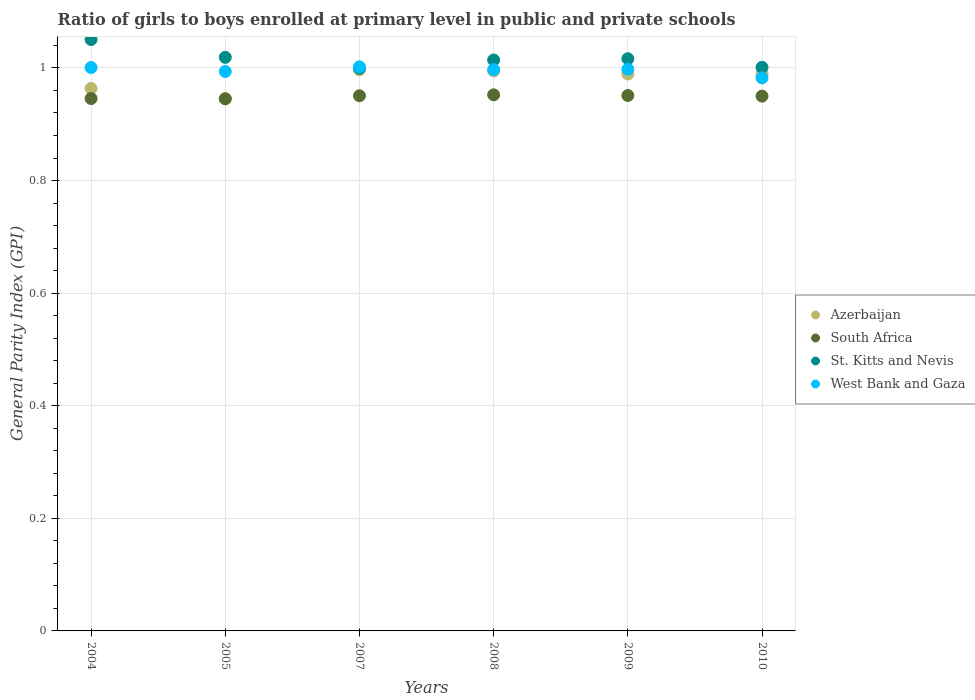Is the number of dotlines equal to the number of legend labels?
Your answer should be very brief. Yes. What is the general parity index in West Bank and Gaza in 2005?
Provide a short and direct response. 0.99. Across all years, what is the maximum general parity index in South Africa?
Give a very brief answer. 0.95. Across all years, what is the minimum general parity index in Azerbaijan?
Your answer should be very brief. 0.95. What is the total general parity index in West Bank and Gaza in the graph?
Give a very brief answer. 5.97. What is the difference between the general parity index in South Africa in 2009 and that in 2010?
Offer a very short reply. 0. What is the difference between the general parity index in South Africa in 2005 and the general parity index in Azerbaijan in 2009?
Give a very brief answer. -0.04. What is the average general parity index in West Bank and Gaza per year?
Offer a terse response. 1. In the year 2004, what is the difference between the general parity index in Azerbaijan and general parity index in South Africa?
Make the answer very short. 0.02. In how many years, is the general parity index in Azerbaijan greater than 0.7200000000000001?
Offer a very short reply. 6. What is the ratio of the general parity index in St. Kitts and Nevis in 2004 to that in 2009?
Ensure brevity in your answer.  1.03. Is the difference between the general parity index in Azerbaijan in 2009 and 2010 greater than the difference between the general parity index in South Africa in 2009 and 2010?
Give a very brief answer. No. What is the difference between the highest and the second highest general parity index in South Africa?
Give a very brief answer. 0. What is the difference between the highest and the lowest general parity index in West Bank and Gaza?
Offer a terse response. 0.02. Is the sum of the general parity index in West Bank and Gaza in 2007 and 2009 greater than the maximum general parity index in St. Kitts and Nevis across all years?
Make the answer very short. Yes. Is it the case that in every year, the sum of the general parity index in Azerbaijan and general parity index in West Bank and Gaza  is greater than the general parity index in St. Kitts and Nevis?
Offer a very short reply. Yes. Does the general parity index in St. Kitts and Nevis monotonically increase over the years?
Offer a very short reply. No. Is the general parity index in West Bank and Gaza strictly greater than the general parity index in St. Kitts and Nevis over the years?
Your answer should be compact. No. Is the general parity index in Azerbaijan strictly less than the general parity index in St. Kitts and Nevis over the years?
Provide a short and direct response. Yes. How many dotlines are there?
Ensure brevity in your answer.  4. Are the values on the major ticks of Y-axis written in scientific E-notation?
Provide a short and direct response. No. Does the graph contain any zero values?
Your answer should be compact. No. Where does the legend appear in the graph?
Your answer should be very brief. Center right. How are the legend labels stacked?
Your response must be concise. Vertical. What is the title of the graph?
Give a very brief answer. Ratio of girls to boys enrolled at primary level in public and private schools. What is the label or title of the Y-axis?
Your response must be concise. General Parity Index (GPI). What is the General Parity Index (GPI) of Azerbaijan in 2004?
Provide a succinct answer. 0.96. What is the General Parity Index (GPI) in South Africa in 2004?
Give a very brief answer. 0.95. What is the General Parity Index (GPI) in St. Kitts and Nevis in 2004?
Make the answer very short. 1.05. What is the General Parity Index (GPI) in West Bank and Gaza in 2004?
Make the answer very short. 1. What is the General Parity Index (GPI) in Azerbaijan in 2005?
Ensure brevity in your answer.  0.95. What is the General Parity Index (GPI) of South Africa in 2005?
Your answer should be very brief. 0.95. What is the General Parity Index (GPI) in St. Kitts and Nevis in 2005?
Provide a short and direct response. 1.02. What is the General Parity Index (GPI) of West Bank and Gaza in 2005?
Offer a very short reply. 0.99. What is the General Parity Index (GPI) in Azerbaijan in 2007?
Ensure brevity in your answer.  1. What is the General Parity Index (GPI) of South Africa in 2007?
Your answer should be compact. 0.95. What is the General Parity Index (GPI) in St. Kitts and Nevis in 2007?
Ensure brevity in your answer.  1. What is the General Parity Index (GPI) in West Bank and Gaza in 2007?
Give a very brief answer. 1. What is the General Parity Index (GPI) in Azerbaijan in 2008?
Provide a short and direct response. 0.99. What is the General Parity Index (GPI) in South Africa in 2008?
Offer a very short reply. 0.95. What is the General Parity Index (GPI) of St. Kitts and Nevis in 2008?
Ensure brevity in your answer.  1.01. What is the General Parity Index (GPI) in West Bank and Gaza in 2008?
Ensure brevity in your answer.  1. What is the General Parity Index (GPI) in Azerbaijan in 2009?
Give a very brief answer. 0.99. What is the General Parity Index (GPI) in South Africa in 2009?
Give a very brief answer. 0.95. What is the General Parity Index (GPI) in St. Kitts and Nevis in 2009?
Your answer should be very brief. 1.02. What is the General Parity Index (GPI) of West Bank and Gaza in 2009?
Give a very brief answer. 1. What is the General Parity Index (GPI) in Azerbaijan in 2010?
Provide a succinct answer. 0.99. What is the General Parity Index (GPI) of South Africa in 2010?
Provide a succinct answer. 0.95. What is the General Parity Index (GPI) of St. Kitts and Nevis in 2010?
Offer a very short reply. 1. What is the General Parity Index (GPI) in West Bank and Gaza in 2010?
Give a very brief answer. 0.98. Across all years, what is the maximum General Parity Index (GPI) in Azerbaijan?
Your answer should be compact. 1. Across all years, what is the maximum General Parity Index (GPI) in South Africa?
Provide a short and direct response. 0.95. Across all years, what is the maximum General Parity Index (GPI) of St. Kitts and Nevis?
Provide a short and direct response. 1.05. Across all years, what is the maximum General Parity Index (GPI) of West Bank and Gaza?
Keep it short and to the point. 1. Across all years, what is the minimum General Parity Index (GPI) of Azerbaijan?
Provide a succinct answer. 0.95. Across all years, what is the minimum General Parity Index (GPI) in South Africa?
Your answer should be very brief. 0.95. Across all years, what is the minimum General Parity Index (GPI) of St. Kitts and Nevis?
Offer a terse response. 1. Across all years, what is the minimum General Parity Index (GPI) in West Bank and Gaza?
Give a very brief answer. 0.98. What is the total General Parity Index (GPI) of Azerbaijan in the graph?
Your answer should be compact. 5.88. What is the total General Parity Index (GPI) of South Africa in the graph?
Your answer should be compact. 5.7. What is the total General Parity Index (GPI) in St. Kitts and Nevis in the graph?
Ensure brevity in your answer.  6.1. What is the total General Parity Index (GPI) of West Bank and Gaza in the graph?
Your response must be concise. 5.97. What is the difference between the General Parity Index (GPI) in Azerbaijan in 2004 and that in 2005?
Give a very brief answer. 0.02. What is the difference between the General Parity Index (GPI) in St. Kitts and Nevis in 2004 and that in 2005?
Offer a terse response. 0.03. What is the difference between the General Parity Index (GPI) in West Bank and Gaza in 2004 and that in 2005?
Offer a very short reply. 0.01. What is the difference between the General Parity Index (GPI) of Azerbaijan in 2004 and that in 2007?
Offer a terse response. -0.03. What is the difference between the General Parity Index (GPI) in South Africa in 2004 and that in 2007?
Your response must be concise. -0. What is the difference between the General Parity Index (GPI) in St. Kitts and Nevis in 2004 and that in 2007?
Your answer should be compact. 0.05. What is the difference between the General Parity Index (GPI) of West Bank and Gaza in 2004 and that in 2007?
Provide a succinct answer. -0. What is the difference between the General Parity Index (GPI) of Azerbaijan in 2004 and that in 2008?
Provide a short and direct response. -0.03. What is the difference between the General Parity Index (GPI) in South Africa in 2004 and that in 2008?
Offer a very short reply. -0.01. What is the difference between the General Parity Index (GPI) in St. Kitts and Nevis in 2004 and that in 2008?
Provide a succinct answer. 0.04. What is the difference between the General Parity Index (GPI) of West Bank and Gaza in 2004 and that in 2008?
Offer a very short reply. 0. What is the difference between the General Parity Index (GPI) of Azerbaijan in 2004 and that in 2009?
Keep it short and to the point. -0.03. What is the difference between the General Parity Index (GPI) of South Africa in 2004 and that in 2009?
Your answer should be very brief. -0.01. What is the difference between the General Parity Index (GPI) of St. Kitts and Nevis in 2004 and that in 2009?
Your answer should be very brief. 0.03. What is the difference between the General Parity Index (GPI) of West Bank and Gaza in 2004 and that in 2009?
Make the answer very short. 0. What is the difference between the General Parity Index (GPI) of Azerbaijan in 2004 and that in 2010?
Ensure brevity in your answer.  -0.03. What is the difference between the General Parity Index (GPI) of South Africa in 2004 and that in 2010?
Provide a short and direct response. -0. What is the difference between the General Parity Index (GPI) in St. Kitts and Nevis in 2004 and that in 2010?
Keep it short and to the point. 0.05. What is the difference between the General Parity Index (GPI) of West Bank and Gaza in 2004 and that in 2010?
Keep it short and to the point. 0.02. What is the difference between the General Parity Index (GPI) in Azerbaijan in 2005 and that in 2007?
Keep it short and to the point. -0.05. What is the difference between the General Parity Index (GPI) of South Africa in 2005 and that in 2007?
Offer a terse response. -0.01. What is the difference between the General Parity Index (GPI) in St. Kitts and Nevis in 2005 and that in 2007?
Provide a short and direct response. 0.02. What is the difference between the General Parity Index (GPI) of West Bank and Gaza in 2005 and that in 2007?
Provide a succinct answer. -0.01. What is the difference between the General Parity Index (GPI) in Azerbaijan in 2005 and that in 2008?
Your answer should be very brief. -0.05. What is the difference between the General Parity Index (GPI) in South Africa in 2005 and that in 2008?
Your response must be concise. -0.01. What is the difference between the General Parity Index (GPI) in St. Kitts and Nevis in 2005 and that in 2008?
Your answer should be compact. 0. What is the difference between the General Parity Index (GPI) in West Bank and Gaza in 2005 and that in 2008?
Make the answer very short. -0. What is the difference between the General Parity Index (GPI) in Azerbaijan in 2005 and that in 2009?
Ensure brevity in your answer.  -0.04. What is the difference between the General Parity Index (GPI) of South Africa in 2005 and that in 2009?
Ensure brevity in your answer.  -0.01. What is the difference between the General Parity Index (GPI) in St. Kitts and Nevis in 2005 and that in 2009?
Offer a terse response. 0. What is the difference between the General Parity Index (GPI) of West Bank and Gaza in 2005 and that in 2009?
Your answer should be compact. -0. What is the difference between the General Parity Index (GPI) of Azerbaijan in 2005 and that in 2010?
Keep it short and to the point. -0.04. What is the difference between the General Parity Index (GPI) of South Africa in 2005 and that in 2010?
Your answer should be compact. -0. What is the difference between the General Parity Index (GPI) in St. Kitts and Nevis in 2005 and that in 2010?
Make the answer very short. 0.02. What is the difference between the General Parity Index (GPI) of West Bank and Gaza in 2005 and that in 2010?
Provide a succinct answer. 0.01. What is the difference between the General Parity Index (GPI) in Azerbaijan in 2007 and that in 2008?
Ensure brevity in your answer.  0. What is the difference between the General Parity Index (GPI) in South Africa in 2007 and that in 2008?
Provide a short and direct response. -0. What is the difference between the General Parity Index (GPI) in St. Kitts and Nevis in 2007 and that in 2008?
Provide a succinct answer. -0.01. What is the difference between the General Parity Index (GPI) in West Bank and Gaza in 2007 and that in 2008?
Keep it short and to the point. 0. What is the difference between the General Parity Index (GPI) of Azerbaijan in 2007 and that in 2009?
Provide a short and direct response. 0.01. What is the difference between the General Parity Index (GPI) in South Africa in 2007 and that in 2009?
Give a very brief answer. -0. What is the difference between the General Parity Index (GPI) in St. Kitts and Nevis in 2007 and that in 2009?
Ensure brevity in your answer.  -0.02. What is the difference between the General Parity Index (GPI) of West Bank and Gaza in 2007 and that in 2009?
Your response must be concise. 0. What is the difference between the General Parity Index (GPI) in Azerbaijan in 2007 and that in 2010?
Provide a succinct answer. 0.01. What is the difference between the General Parity Index (GPI) in South Africa in 2007 and that in 2010?
Ensure brevity in your answer.  0. What is the difference between the General Parity Index (GPI) in St. Kitts and Nevis in 2007 and that in 2010?
Offer a terse response. -0. What is the difference between the General Parity Index (GPI) in West Bank and Gaza in 2007 and that in 2010?
Provide a succinct answer. 0.02. What is the difference between the General Parity Index (GPI) in Azerbaijan in 2008 and that in 2009?
Keep it short and to the point. 0.01. What is the difference between the General Parity Index (GPI) in South Africa in 2008 and that in 2009?
Your answer should be compact. 0. What is the difference between the General Parity Index (GPI) in St. Kitts and Nevis in 2008 and that in 2009?
Provide a succinct answer. -0. What is the difference between the General Parity Index (GPI) of West Bank and Gaza in 2008 and that in 2009?
Offer a very short reply. -0. What is the difference between the General Parity Index (GPI) in Azerbaijan in 2008 and that in 2010?
Provide a short and direct response. 0.01. What is the difference between the General Parity Index (GPI) of South Africa in 2008 and that in 2010?
Offer a very short reply. 0. What is the difference between the General Parity Index (GPI) of St. Kitts and Nevis in 2008 and that in 2010?
Give a very brief answer. 0.01. What is the difference between the General Parity Index (GPI) of West Bank and Gaza in 2008 and that in 2010?
Provide a succinct answer. 0.01. What is the difference between the General Parity Index (GPI) of Azerbaijan in 2009 and that in 2010?
Your response must be concise. -0. What is the difference between the General Parity Index (GPI) of South Africa in 2009 and that in 2010?
Provide a succinct answer. 0. What is the difference between the General Parity Index (GPI) of St. Kitts and Nevis in 2009 and that in 2010?
Make the answer very short. 0.02. What is the difference between the General Parity Index (GPI) in West Bank and Gaza in 2009 and that in 2010?
Provide a short and direct response. 0.02. What is the difference between the General Parity Index (GPI) of Azerbaijan in 2004 and the General Parity Index (GPI) of South Africa in 2005?
Provide a short and direct response. 0.02. What is the difference between the General Parity Index (GPI) of Azerbaijan in 2004 and the General Parity Index (GPI) of St. Kitts and Nevis in 2005?
Offer a very short reply. -0.06. What is the difference between the General Parity Index (GPI) of Azerbaijan in 2004 and the General Parity Index (GPI) of West Bank and Gaza in 2005?
Offer a very short reply. -0.03. What is the difference between the General Parity Index (GPI) of South Africa in 2004 and the General Parity Index (GPI) of St. Kitts and Nevis in 2005?
Ensure brevity in your answer.  -0.07. What is the difference between the General Parity Index (GPI) in South Africa in 2004 and the General Parity Index (GPI) in West Bank and Gaza in 2005?
Give a very brief answer. -0.05. What is the difference between the General Parity Index (GPI) in St. Kitts and Nevis in 2004 and the General Parity Index (GPI) in West Bank and Gaza in 2005?
Offer a terse response. 0.06. What is the difference between the General Parity Index (GPI) in Azerbaijan in 2004 and the General Parity Index (GPI) in South Africa in 2007?
Offer a very short reply. 0.01. What is the difference between the General Parity Index (GPI) in Azerbaijan in 2004 and the General Parity Index (GPI) in St. Kitts and Nevis in 2007?
Make the answer very short. -0.04. What is the difference between the General Parity Index (GPI) in Azerbaijan in 2004 and the General Parity Index (GPI) in West Bank and Gaza in 2007?
Ensure brevity in your answer.  -0.04. What is the difference between the General Parity Index (GPI) in South Africa in 2004 and the General Parity Index (GPI) in St. Kitts and Nevis in 2007?
Keep it short and to the point. -0.05. What is the difference between the General Parity Index (GPI) of South Africa in 2004 and the General Parity Index (GPI) of West Bank and Gaza in 2007?
Offer a terse response. -0.06. What is the difference between the General Parity Index (GPI) in St. Kitts and Nevis in 2004 and the General Parity Index (GPI) in West Bank and Gaza in 2007?
Provide a short and direct response. 0.05. What is the difference between the General Parity Index (GPI) in Azerbaijan in 2004 and the General Parity Index (GPI) in South Africa in 2008?
Your response must be concise. 0.01. What is the difference between the General Parity Index (GPI) in Azerbaijan in 2004 and the General Parity Index (GPI) in St. Kitts and Nevis in 2008?
Your answer should be compact. -0.05. What is the difference between the General Parity Index (GPI) in Azerbaijan in 2004 and the General Parity Index (GPI) in West Bank and Gaza in 2008?
Ensure brevity in your answer.  -0.03. What is the difference between the General Parity Index (GPI) of South Africa in 2004 and the General Parity Index (GPI) of St. Kitts and Nevis in 2008?
Provide a succinct answer. -0.07. What is the difference between the General Parity Index (GPI) of South Africa in 2004 and the General Parity Index (GPI) of West Bank and Gaza in 2008?
Your answer should be very brief. -0.05. What is the difference between the General Parity Index (GPI) of St. Kitts and Nevis in 2004 and the General Parity Index (GPI) of West Bank and Gaza in 2008?
Your answer should be compact. 0.05. What is the difference between the General Parity Index (GPI) of Azerbaijan in 2004 and the General Parity Index (GPI) of South Africa in 2009?
Your answer should be compact. 0.01. What is the difference between the General Parity Index (GPI) in Azerbaijan in 2004 and the General Parity Index (GPI) in St. Kitts and Nevis in 2009?
Keep it short and to the point. -0.05. What is the difference between the General Parity Index (GPI) of Azerbaijan in 2004 and the General Parity Index (GPI) of West Bank and Gaza in 2009?
Give a very brief answer. -0.03. What is the difference between the General Parity Index (GPI) in South Africa in 2004 and the General Parity Index (GPI) in St. Kitts and Nevis in 2009?
Your answer should be compact. -0.07. What is the difference between the General Parity Index (GPI) in South Africa in 2004 and the General Parity Index (GPI) in West Bank and Gaza in 2009?
Your answer should be very brief. -0.05. What is the difference between the General Parity Index (GPI) of St. Kitts and Nevis in 2004 and the General Parity Index (GPI) of West Bank and Gaza in 2009?
Your answer should be compact. 0.05. What is the difference between the General Parity Index (GPI) of Azerbaijan in 2004 and the General Parity Index (GPI) of South Africa in 2010?
Provide a short and direct response. 0.01. What is the difference between the General Parity Index (GPI) of Azerbaijan in 2004 and the General Parity Index (GPI) of St. Kitts and Nevis in 2010?
Provide a succinct answer. -0.04. What is the difference between the General Parity Index (GPI) in Azerbaijan in 2004 and the General Parity Index (GPI) in West Bank and Gaza in 2010?
Keep it short and to the point. -0.02. What is the difference between the General Parity Index (GPI) in South Africa in 2004 and the General Parity Index (GPI) in St. Kitts and Nevis in 2010?
Make the answer very short. -0.06. What is the difference between the General Parity Index (GPI) of South Africa in 2004 and the General Parity Index (GPI) of West Bank and Gaza in 2010?
Ensure brevity in your answer.  -0.04. What is the difference between the General Parity Index (GPI) in St. Kitts and Nevis in 2004 and the General Parity Index (GPI) in West Bank and Gaza in 2010?
Make the answer very short. 0.07. What is the difference between the General Parity Index (GPI) in Azerbaijan in 2005 and the General Parity Index (GPI) in South Africa in 2007?
Offer a terse response. -0.01. What is the difference between the General Parity Index (GPI) in Azerbaijan in 2005 and the General Parity Index (GPI) in St. Kitts and Nevis in 2007?
Offer a terse response. -0.05. What is the difference between the General Parity Index (GPI) in Azerbaijan in 2005 and the General Parity Index (GPI) in West Bank and Gaza in 2007?
Offer a very short reply. -0.06. What is the difference between the General Parity Index (GPI) in South Africa in 2005 and the General Parity Index (GPI) in St. Kitts and Nevis in 2007?
Offer a terse response. -0.05. What is the difference between the General Parity Index (GPI) in South Africa in 2005 and the General Parity Index (GPI) in West Bank and Gaza in 2007?
Offer a very short reply. -0.06. What is the difference between the General Parity Index (GPI) in St. Kitts and Nevis in 2005 and the General Parity Index (GPI) in West Bank and Gaza in 2007?
Keep it short and to the point. 0.02. What is the difference between the General Parity Index (GPI) in Azerbaijan in 2005 and the General Parity Index (GPI) in South Africa in 2008?
Your response must be concise. -0.01. What is the difference between the General Parity Index (GPI) of Azerbaijan in 2005 and the General Parity Index (GPI) of St. Kitts and Nevis in 2008?
Keep it short and to the point. -0.07. What is the difference between the General Parity Index (GPI) in Azerbaijan in 2005 and the General Parity Index (GPI) in West Bank and Gaza in 2008?
Your answer should be very brief. -0.05. What is the difference between the General Parity Index (GPI) of South Africa in 2005 and the General Parity Index (GPI) of St. Kitts and Nevis in 2008?
Give a very brief answer. -0.07. What is the difference between the General Parity Index (GPI) in South Africa in 2005 and the General Parity Index (GPI) in West Bank and Gaza in 2008?
Offer a terse response. -0.05. What is the difference between the General Parity Index (GPI) in St. Kitts and Nevis in 2005 and the General Parity Index (GPI) in West Bank and Gaza in 2008?
Your answer should be very brief. 0.02. What is the difference between the General Parity Index (GPI) in Azerbaijan in 2005 and the General Parity Index (GPI) in South Africa in 2009?
Offer a very short reply. -0.01. What is the difference between the General Parity Index (GPI) of Azerbaijan in 2005 and the General Parity Index (GPI) of St. Kitts and Nevis in 2009?
Provide a short and direct response. -0.07. What is the difference between the General Parity Index (GPI) in Azerbaijan in 2005 and the General Parity Index (GPI) in West Bank and Gaza in 2009?
Give a very brief answer. -0.05. What is the difference between the General Parity Index (GPI) in South Africa in 2005 and the General Parity Index (GPI) in St. Kitts and Nevis in 2009?
Provide a succinct answer. -0.07. What is the difference between the General Parity Index (GPI) in South Africa in 2005 and the General Parity Index (GPI) in West Bank and Gaza in 2009?
Your answer should be very brief. -0.05. What is the difference between the General Parity Index (GPI) in St. Kitts and Nevis in 2005 and the General Parity Index (GPI) in West Bank and Gaza in 2009?
Ensure brevity in your answer.  0.02. What is the difference between the General Parity Index (GPI) in Azerbaijan in 2005 and the General Parity Index (GPI) in South Africa in 2010?
Provide a succinct answer. -0. What is the difference between the General Parity Index (GPI) in Azerbaijan in 2005 and the General Parity Index (GPI) in St. Kitts and Nevis in 2010?
Offer a very short reply. -0.06. What is the difference between the General Parity Index (GPI) in Azerbaijan in 2005 and the General Parity Index (GPI) in West Bank and Gaza in 2010?
Provide a succinct answer. -0.04. What is the difference between the General Parity Index (GPI) in South Africa in 2005 and the General Parity Index (GPI) in St. Kitts and Nevis in 2010?
Ensure brevity in your answer.  -0.06. What is the difference between the General Parity Index (GPI) of South Africa in 2005 and the General Parity Index (GPI) of West Bank and Gaza in 2010?
Your answer should be compact. -0.04. What is the difference between the General Parity Index (GPI) of St. Kitts and Nevis in 2005 and the General Parity Index (GPI) of West Bank and Gaza in 2010?
Your answer should be very brief. 0.04. What is the difference between the General Parity Index (GPI) in Azerbaijan in 2007 and the General Parity Index (GPI) in South Africa in 2008?
Make the answer very short. 0.04. What is the difference between the General Parity Index (GPI) of Azerbaijan in 2007 and the General Parity Index (GPI) of St. Kitts and Nevis in 2008?
Offer a terse response. -0.02. What is the difference between the General Parity Index (GPI) in Azerbaijan in 2007 and the General Parity Index (GPI) in West Bank and Gaza in 2008?
Offer a terse response. -0. What is the difference between the General Parity Index (GPI) of South Africa in 2007 and the General Parity Index (GPI) of St. Kitts and Nevis in 2008?
Provide a short and direct response. -0.06. What is the difference between the General Parity Index (GPI) in South Africa in 2007 and the General Parity Index (GPI) in West Bank and Gaza in 2008?
Your response must be concise. -0.05. What is the difference between the General Parity Index (GPI) in St. Kitts and Nevis in 2007 and the General Parity Index (GPI) in West Bank and Gaza in 2008?
Give a very brief answer. 0. What is the difference between the General Parity Index (GPI) in Azerbaijan in 2007 and the General Parity Index (GPI) in South Africa in 2009?
Keep it short and to the point. 0.05. What is the difference between the General Parity Index (GPI) in Azerbaijan in 2007 and the General Parity Index (GPI) in St. Kitts and Nevis in 2009?
Provide a short and direct response. -0.02. What is the difference between the General Parity Index (GPI) in Azerbaijan in 2007 and the General Parity Index (GPI) in West Bank and Gaza in 2009?
Your answer should be compact. -0. What is the difference between the General Parity Index (GPI) in South Africa in 2007 and the General Parity Index (GPI) in St. Kitts and Nevis in 2009?
Make the answer very short. -0.07. What is the difference between the General Parity Index (GPI) in South Africa in 2007 and the General Parity Index (GPI) in West Bank and Gaza in 2009?
Make the answer very short. -0.05. What is the difference between the General Parity Index (GPI) in St. Kitts and Nevis in 2007 and the General Parity Index (GPI) in West Bank and Gaza in 2009?
Keep it short and to the point. 0. What is the difference between the General Parity Index (GPI) of Azerbaijan in 2007 and the General Parity Index (GPI) of South Africa in 2010?
Your response must be concise. 0.05. What is the difference between the General Parity Index (GPI) of Azerbaijan in 2007 and the General Parity Index (GPI) of St. Kitts and Nevis in 2010?
Give a very brief answer. -0. What is the difference between the General Parity Index (GPI) in Azerbaijan in 2007 and the General Parity Index (GPI) in West Bank and Gaza in 2010?
Offer a very short reply. 0.01. What is the difference between the General Parity Index (GPI) of South Africa in 2007 and the General Parity Index (GPI) of St. Kitts and Nevis in 2010?
Keep it short and to the point. -0.05. What is the difference between the General Parity Index (GPI) in South Africa in 2007 and the General Parity Index (GPI) in West Bank and Gaza in 2010?
Offer a terse response. -0.03. What is the difference between the General Parity Index (GPI) of St. Kitts and Nevis in 2007 and the General Parity Index (GPI) of West Bank and Gaza in 2010?
Offer a terse response. 0.02. What is the difference between the General Parity Index (GPI) in Azerbaijan in 2008 and the General Parity Index (GPI) in South Africa in 2009?
Your response must be concise. 0.04. What is the difference between the General Parity Index (GPI) of Azerbaijan in 2008 and the General Parity Index (GPI) of St. Kitts and Nevis in 2009?
Offer a very short reply. -0.02. What is the difference between the General Parity Index (GPI) in Azerbaijan in 2008 and the General Parity Index (GPI) in West Bank and Gaza in 2009?
Offer a very short reply. -0. What is the difference between the General Parity Index (GPI) of South Africa in 2008 and the General Parity Index (GPI) of St. Kitts and Nevis in 2009?
Your response must be concise. -0.06. What is the difference between the General Parity Index (GPI) in South Africa in 2008 and the General Parity Index (GPI) in West Bank and Gaza in 2009?
Your answer should be compact. -0.05. What is the difference between the General Parity Index (GPI) in St. Kitts and Nevis in 2008 and the General Parity Index (GPI) in West Bank and Gaza in 2009?
Your answer should be very brief. 0.02. What is the difference between the General Parity Index (GPI) in Azerbaijan in 2008 and the General Parity Index (GPI) in South Africa in 2010?
Provide a succinct answer. 0.04. What is the difference between the General Parity Index (GPI) of Azerbaijan in 2008 and the General Parity Index (GPI) of St. Kitts and Nevis in 2010?
Ensure brevity in your answer.  -0.01. What is the difference between the General Parity Index (GPI) in Azerbaijan in 2008 and the General Parity Index (GPI) in West Bank and Gaza in 2010?
Ensure brevity in your answer.  0.01. What is the difference between the General Parity Index (GPI) in South Africa in 2008 and the General Parity Index (GPI) in St. Kitts and Nevis in 2010?
Your response must be concise. -0.05. What is the difference between the General Parity Index (GPI) of South Africa in 2008 and the General Parity Index (GPI) of West Bank and Gaza in 2010?
Provide a short and direct response. -0.03. What is the difference between the General Parity Index (GPI) of St. Kitts and Nevis in 2008 and the General Parity Index (GPI) of West Bank and Gaza in 2010?
Offer a terse response. 0.03. What is the difference between the General Parity Index (GPI) of Azerbaijan in 2009 and the General Parity Index (GPI) of South Africa in 2010?
Provide a succinct answer. 0.04. What is the difference between the General Parity Index (GPI) of Azerbaijan in 2009 and the General Parity Index (GPI) of St. Kitts and Nevis in 2010?
Your answer should be compact. -0.01. What is the difference between the General Parity Index (GPI) in Azerbaijan in 2009 and the General Parity Index (GPI) in West Bank and Gaza in 2010?
Ensure brevity in your answer.  0.01. What is the difference between the General Parity Index (GPI) of South Africa in 2009 and the General Parity Index (GPI) of West Bank and Gaza in 2010?
Offer a very short reply. -0.03. What is the difference between the General Parity Index (GPI) in St. Kitts and Nevis in 2009 and the General Parity Index (GPI) in West Bank and Gaza in 2010?
Give a very brief answer. 0.03. What is the average General Parity Index (GPI) in Azerbaijan per year?
Offer a terse response. 0.98. What is the average General Parity Index (GPI) of South Africa per year?
Your answer should be compact. 0.95. What is the average General Parity Index (GPI) of St. Kitts and Nevis per year?
Give a very brief answer. 1.02. In the year 2004, what is the difference between the General Parity Index (GPI) in Azerbaijan and General Parity Index (GPI) in South Africa?
Your response must be concise. 0.02. In the year 2004, what is the difference between the General Parity Index (GPI) in Azerbaijan and General Parity Index (GPI) in St. Kitts and Nevis?
Your answer should be very brief. -0.09. In the year 2004, what is the difference between the General Parity Index (GPI) in Azerbaijan and General Parity Index (GPI) in West Bank and Gaza?
Your response must be concise. -0.04. In the year 2004, what is the difference between the General Parity Index (GPI) in South Africa and General Parity Index (GPI) in St. Kitts and Nevis?
Provide a short and direct response. -0.1. In the year 2004, what is the difference between the General Parity Index (GPI) of South Africa and General Parity Index (GPI) of West Bank and Gaza?
Keep it short and to the point. -0.06. In the year 2004, what is the difference between the General Parity Index (GPI) in St. Kitts and Nevis and General Parity Index (GPI) in West Bank and Gaza?
Your answer should be compact. 0.05. In the year 2005, what is the difference between the General Parity Index (GPI) of Azerbaijan and General Parity Index (GPI) of South Africa?
Provide a short and direct response. -0. In the year 2005, what is the difference between the General Parity Index (GPI) in Azerbaijan and General Parity Index (GPI) in St. Kitts and Nevis?
Make the answer very short. -0.07. In the year 2005, what is the difference between the General Parity Index (GPI) of Azerbaijan and General Parity Index (GPI) of West Bank and Gaza?
Provide a succinct answer. -0.05. In the year 2005, what is the difference between the General Parity Index (GPI) of South Africa and General Parity Index (GPI) of St. Kitts and Nevis?
Provide a short and direct response. -0.07. In the year 2005, what is the difference between the General Parity Index (GPI) in South Africa and General Parity Index (GPI) in West Bank and Gaza?
Offer a terse response. -0.05. In the year 2005, what is the difference between the General Parity Index (GPI) of St. Kitts and Nevis and General Parity Index (GPI) of West Bank and Gaza?
Your answer should be compact. 0.03. In the year 2007, what is the difference between the General Parity Index (GPI) in Azerbaijan and General Parity Index (GPI) in South Africa?
Your answer should be very brief. 0.05. In the year 2007, what is the difference between the General Parity Index (GPI) in Azerbaijan and General Parity Index (GPI) in St. Kitts and Nevis?
Give a very brief answer. -0. In the year 2007, what is the difference between the General Parity Index (GPI) in Azerbaijan and General Parity Index (GPI) in West Bank and Gaza?
Your answer should be compact. -0.01. In the year 2007, what is the difference between the General Parity Index (GPI) of South Africa and General Parity Index (GPI) of St. Kitts and Nevis?
Provide a succinct answer. -0.05. In the year 2007, what is the difference between the General Parity Index (GPI) of South Africa and General Parity Index (GPI) of West Bank and Gaza?
Make the answer very short. -0.05. In the year 2007, what is the difference between the General Parity Index (GPI) in St. Kitts and Nevis and General Parity Index (GPI) in West Bank and Gaza?
Your answer should be very brief. -0. In the year 2008, what is the difference between the General Parity Index (GPI) of Azerbaijan and General Parity Index (GPI) of South Africa?
Your answer should be compact. 0.04. In the year 2008, what is the difference between the General Parity Index (GPI) of Azerbaijan and General Parity Index (GPI) of St. Kitts and Nevis?
Your answer should be very brief. -0.02. In the year 2008, what is the difference between the General Parity Index (GPI) in Azerbaijan and General Parity Index (GPI) in West Bank and Gaza?
Make the answer very short. -0. In the year 2008, what is the difference between the General Parity Index (GPI) in South Africa and General Parity Index (GPI) in St. Kitts and Nevis?
Make the answer very short. -0.06. In the year 2008, what is the difference between the General Parity Index (GPI) in South Africa and General Parity Index (GPI) in West Bank and Gaza?
Provide a short and direct response. -0.04. In the year 2008, what is the difference between the General Parity Index (GPI) in St. Kitts and Nevis and General Parity Index (GPI) in West Bank and Gaza?
Keep it short and to the point. 0.02. In the year 2009, what is the difference between the General Parity Index (GPI) in Azerbaijan and General Parity Index (GPI) in South Africa?
Your answer should be compact. 0.04. In the year 2009, what is the difference between the General Parity Index (GPI) in Azerbaijan and General Parity Index (GPI) in St. Kitts and Nevis?
Give a very brief answer. -0.03. In the year 2009, what is the difference between the General Parity Index (GPI) of Azerbaijan and General Parity Index (GPI) of West Bank and Gaza?
Give a very brief answer. -0.01. In the year 2009, what is the difference between the General Parity Index (GPI) in South Africa and General Parity Index (GPI) in St. Kitts and Nevis?
Ensure brevity in your answer.  -0.07. In the year 2009, what is the difference between the General Parity Index (GPI) in South Africa and General Parity Index (GPI) in West Bank and Gaza?
Make the answer very short. -0.05. In the year 2009, what is the difference between the General Parity Index (GPI) of St. Kitts and Nevis and General Parity Index (GPI) of West Bank and Gaza?
Offer a terse response. 0.02. In the year 2010, what is the difference between the General Parity Index (GPI) of Azerbaijan and General Parity Index (GPI) of South Africa?
Make the answer very short. 0.04. In the year 2010, what is the difference between the General Parity Index (GPI) in Azerbaijan and General Parity Index (GPI) in St. Kitts and Nevis?
Provide a succinct answer. -0.01. In the year 2010, what is the difference between the General Parity Index (GPI) in Azerbaijan and General Parity Index (GPI) in West Bank and Gaza?
Your answer should be very brief. 0.01. In the year 2010, what is the difference between the General Parity Index (GPI) of South Africa and General Parity Index (GPI) of St. Kitts and Nevis?
Your answer should be compact. -0.05. In the year 2010, what is the difference between the General Parity Index (GPI) in South Africa and General Parity Index (GPI) in West Bank and Gaza?
Your answer should be compact. -0.03. In the year 2010, what is the difference between the General Parity Index (GPI) of St. Kitts and Nevis and General Parity Index (GPI) of West Bank and Gaza?
Offer a very short reply. 0.02. What is the ratio of the General Parity Index (GPI) in Azerbaijan in 2004 to that in 2005?
Give a very brief answer. 1.02. What is the ratio of the General Parity Index (GPI) in St. Kitts and Nevis in 2004 to that in 2005?
Offer a terse response. 1.03. What is the ratio of the General Parity Index (GPI) of West Bank and Gaza in 2004 to that in 2005?
Provide a succinct answer. 1.01. What is the ratio of the General Parity Index (GPI) in Azerbaijan in 2004 to that in 2007?
Make the answer very short. 0.97. What is the ratio of the General Parity Index (GPI) in South Africa in 2004 to that in 2007?
Give a very brief answer. 0.99. What is the ratio of the General Parity Index (GPI) of St. Kitts and Nevis in 2004 to that in 2007?
Your response must be concise. 1.05. What is the ratio of the General Parity Index (GPI) of Azerbaijan in 2004 to that in 2008?
Ensure brevity in your answer.  0.97. What is the ratio of the General Parity Index (GPI) in South Africa in 2004 to that in 2008?
Your response must be concise. 0.99. What is the ratio of the General Parity Index (GPI) of St. Kitts and Nevis in 2004 to that in 2008?
Offer a terse response. 1.04. What is the ratio of the General Parity Index (GPI) of West Bank and Gaza in 2004 to that in 2008?
Give a very brief answer. 1. What is the ratio of the General Parity Index (GPI) in Azerbaijan in 2004 to that in 2009?
Your answer should be compact. 0.97. What is the ratio of the General Parity Index (GPI) in St. Kitts and Nevis in 2004 to that in 2009?
Offer a very short reply. 1.03. What is the ratio of the General Parity Index (GPI) in Azerbaijan in 2004 to that in 2010?
Offer a terse response. 0.97. What is the ratio of the General Parity Index (GPI) in South Africa in 2004 to that in 2010?
Your answer should be very brief. 1. What is the ratio of the General Parity Index (GPI) of St. Kitts and Nevis in 2004 to that in 2010?
Your response must be concise. 1.05. What is the ratio of the General Parity Index (GPI) of West Bank and Gaza in 2004 to that in 2010?
Ensure brevity in your answer.  1.02. What is the ratio of the General Parity Index (GPI) of Azerbaijan in 2005 to that in 2007?
Your response must be concise. 0.95. What is the ratio of the General Parity Index (GPI) of South Africa in 2005 to that in 2007?
Make the answer very short. 0.99. What is the ratio of the General Parity Index (GPI) in St. Kitts and Nevis in 2005 to that in 2007?
Provide a succinct answer. 1.02. What is the ratio of the General Parity Index (GPI) in Azerbaijan in 2005 to that in 2008?
Give a very brief answer. 0.95. What is the ratio of the General Parity Index (GPI) in St. Kitts and Nevis in 2005 to that in 2008?
Your answer should be very brief. 1. What is the ratio of the General Parity Index (GPI) of Azerbaijan in 2005 to that in 2009?
Provide a short and direct response. 0.96. What is the ratio of the General Parity Index (GPI) in St. Kitts and Nevis in 2005 to that in 2009?
Give a very brief answer. 1. What is the ratio of the General Parity Index (GPI) in Azerbaijan in 2005 to that in 2010?
Offer a terse response. 0.96. What is the ratio of the General Parity Index (GPI) in South Africa in 2005 to that in 2010?
Your answer should be very brief. 1. What is the ratio of the General Parity Index (GPI) in St. Kitts and Nevis in 2005 to that in 2010?
Make the answer very short. 1.02. What is the ratio of the General Parity Index (GPI) of West Bank and Gaza in 2005 to that in 2010?
Provide a succinct answer. 1.01. What is the ratio of the General Parity Index (GPI) of South Africa in 2007 to that in 2008?
Ensure brevity in your answer.  1. What is the ratio of the General Parity Index (GPI) of St. Kitts and Nevis in 2007 to that in 2008?
Provide a short and direct response. 0.99. What is the ratio of the General Parity Index (GPI) of Azerbaijan in 2007 to that in 2009?
Offer a terse response. 1.01. What is the ratio of the General Parity Index (GPI) in South Africa in 2007 to that in 2009?
Your answer should be compact. 1. What is the ratio of the General Parity Index (GPI) of St. Kitts and Nevis in 2007 to that in 2009?
Provide a succinct answer. 0.98. What is the ratio of the General Parity Index (GPI) of West Bank and Gaza in 2007 to that in 2009?
Your answer should be compact. 1. What is the ratio of the General Parity Index (GPI) of Azerbaijan in 2007 to that in 2010?
Offer a very short reply. 1.01. What is the ratio of the General Parity Index (GPI) in South Africa in 2007 to that in 2010?
Ensure brevity in your answer.  1. What is the ratio of the General Parity Index (GPI) in St. Kitts and Nevis in 2007 to that in 2010?
Give a very brief answer. 1. What is the ratio of the General Parity Index (GPI) of West Bank and Gaza in 2007 to that in 2010?
Your response must be concise. 1.02. What is the ratio of the General Parity Index (GPI) in Azerbaijan in 2008 to that in 2009?
Make the answer very short. 1.01. What is the ratio of the General Parity Index (GPI) of South Africa in 2008 to that in 2009?
Provide a succinct answer. 1. What is the ratio of the General Parity Index (GPI) in St. Kitts and Nevis in 2008 to that in 2009?
Provide a succinct answer. 1. What is the ratio of the General Parity Index (GPI) of South Africa in 2008 to that in 2010?
Provide a succinct answer. 1. What is the ratio of the General Parity Index (GPI) of St. Kitts and Nevis in 2008 to that in 2010?
Provide a short and direct response. 1.01. What is the ratio of the General Parity Index (GPI) of West Bank and Gaza in 2008 to that in 2010?
Ensure brevity in your answer.  1.01. What is the ratio of the General Parity Index (GPI) of Azerbaijan in 2009 to that in 2010?
Provide a short and direct response. 1. What is the ratio of the General Parity Index (GPI) in St. Kitts and Nevis in 2009 to that in 2010?
Offer a very short reply. 1.02. What is the ratio of the General Parity Index (GPI) in West Bank and Gaza in 2009 to that in 2010?
Make the answer very short. 1.02. What is the difference between the highest and the second highest General Parity Index (GPI) in Azerbaijan?
Give a very brief answer. 0. What is the difference between the highest and the second highest General Parity Index (GPI) of South Africa?
Provide a succinct answer. 0. What is the difference between the highest and the second highest General Parity Index (GPI) of St. Kitts and Nevis?
Provide a succinct answer. 0.03. What is the difference between the highest and the second highest General Parity Index (GPI) in West Bank and Gaza?
Offer a terse response. 0. What is the difference between the highest and the lowest General Parity Index (GPI) of Azerbaijan?
Keep it short and to the point. 0.05. What is the difference between the highest and the lowest General Parity Index (GPI) in South Africa?
Make the answer very short. 0.01. What is the difference between the highest and the lowest General Parity Index (GPI) of St. Kitts and Nevis?
Your answer should be very brief. 0.05. What is the difference between the highest and the lowest General Parity Index (GPI) of West Bank and Gaza?
Your answer should be very brief. 0.02. 